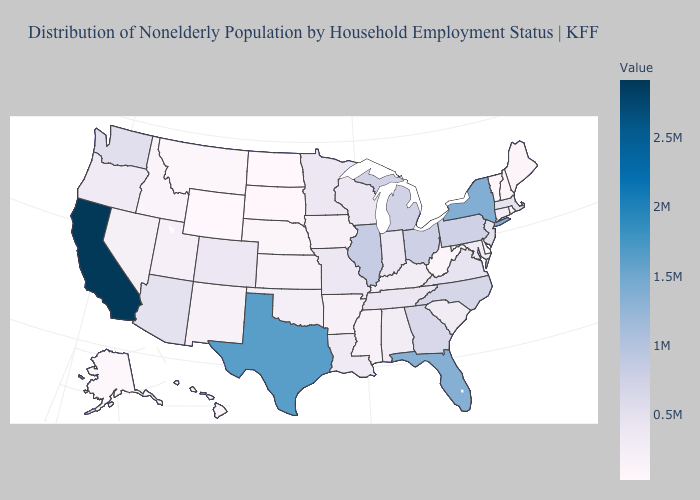Does Nevada have the highest value in the West?
Answer briefly. No. Does Rhode Island have a higher value than Texas?
Concise answer only. No. Which states have the highest value in the USA?
Give a very brief answer. California. Which states have the highest value in the USA?
Write a very short answer. California. Which states hav the highest value in the West?
Concise answer only. California. 